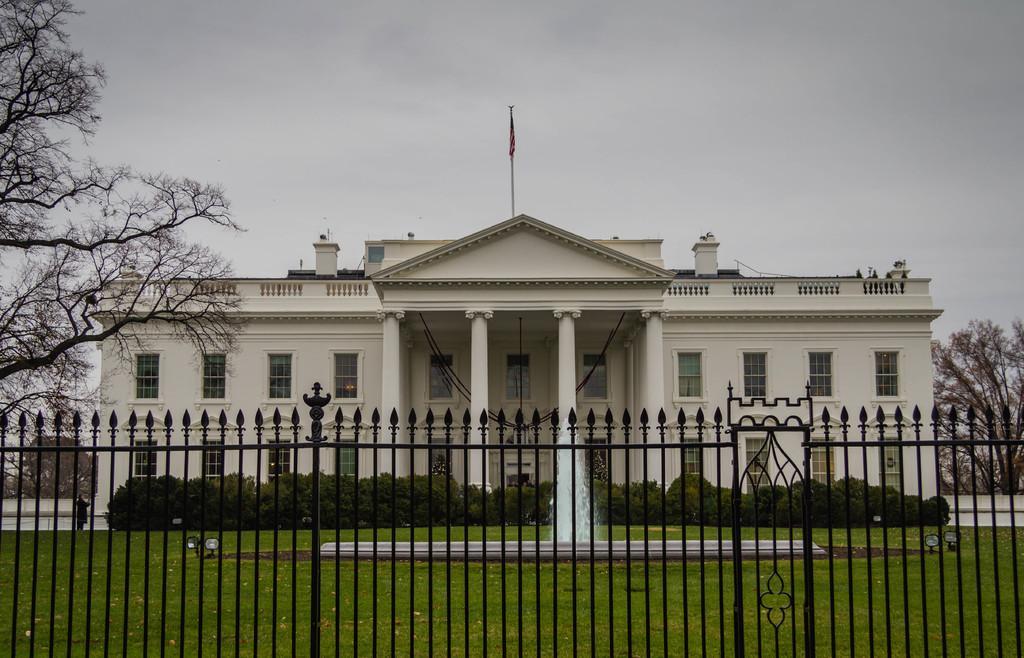Can you describe this image briefly? In this image we can see the building. And we can see the windows. And we can see the water fountain in front of the building and we can see the flag on the building. And we can see the clouds. And we can see the dried trees and plants. And we can see the metal fencing and lights. 